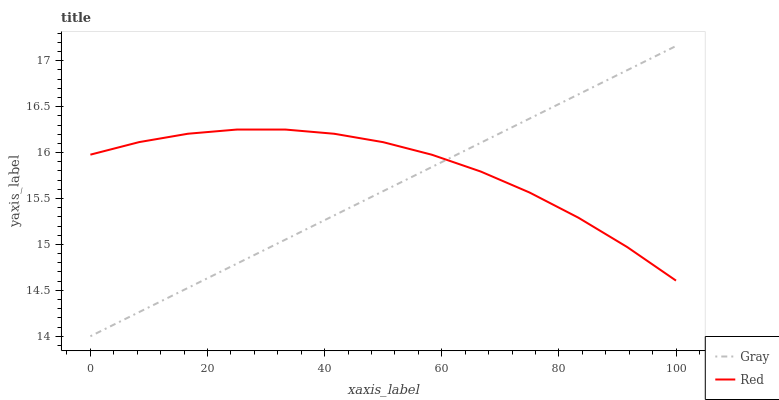Does Red have the minimum area under the curve?
Answer yes or no. No. Is Red the smoothest?
Answer yes or no. No. Does Red have the lowest value?
Answer yes or no. No. Does Red have the highest value?
Answer yes or no. No. 